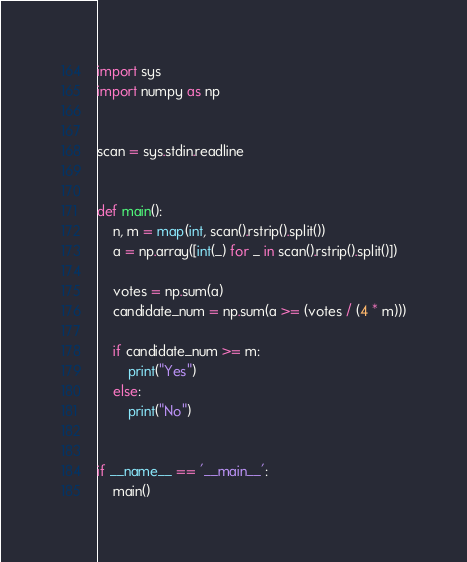<code> <loc_0><loc_0><loc_500><loc_500><_Python_>import sys
import numpy as np


scan = sys.stdin.readline


def main():
    n, m = map(int, scan().rstrip().split())
    a = np.array([int(_) for _ in scan().rstrip().split()])

    votes = np.sum(a)
    candidate_num = np.sum(a >= (votes / (4 * m)))
    
    if candidate_num >= m:
        print("Yes")
    else:
        print("No")


if __name__ == '__main__':
    main()
</code> 